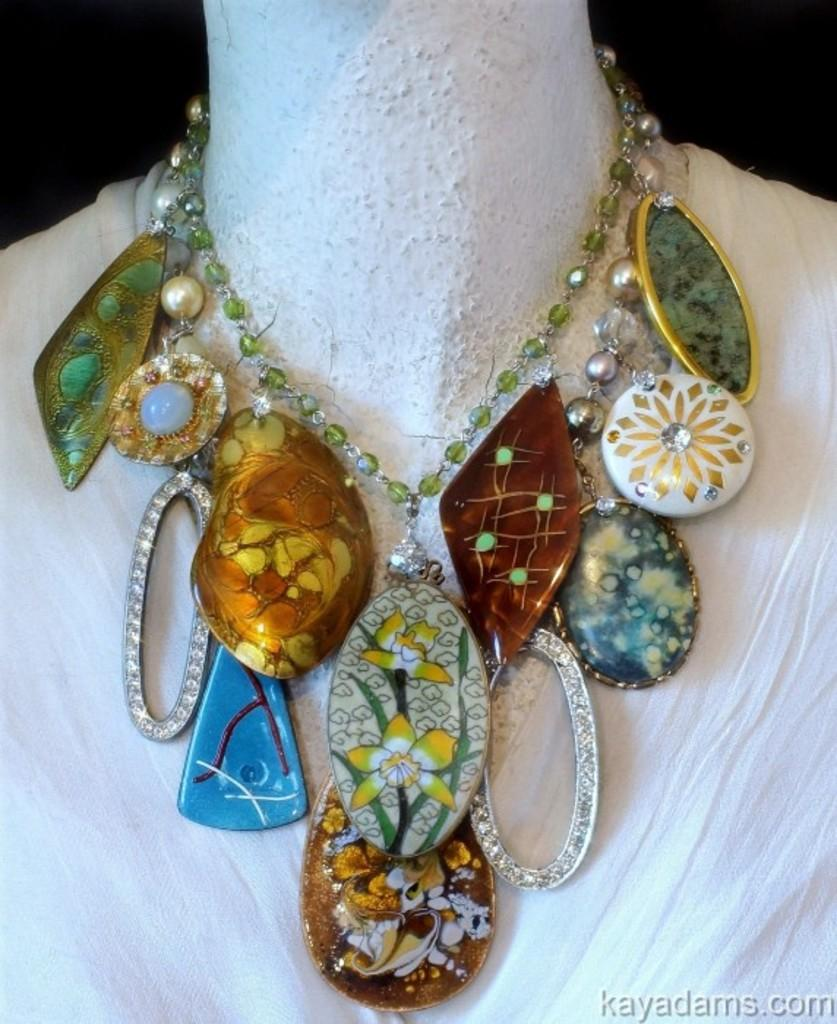What is the main subject in the image? There is a mannequin in the image. What is the mannequin wearing? The mannequin is wearing a necklace. Where can text or writing be found in the image? There is text or writing in the right bottom corner of the image. What type of science experiment is being conducted by the mannequin in the image? There is no science experiment or any indication of a fight in the image; it only features a mannequin wearing a necklace and text or writing in the right bottom corner. 